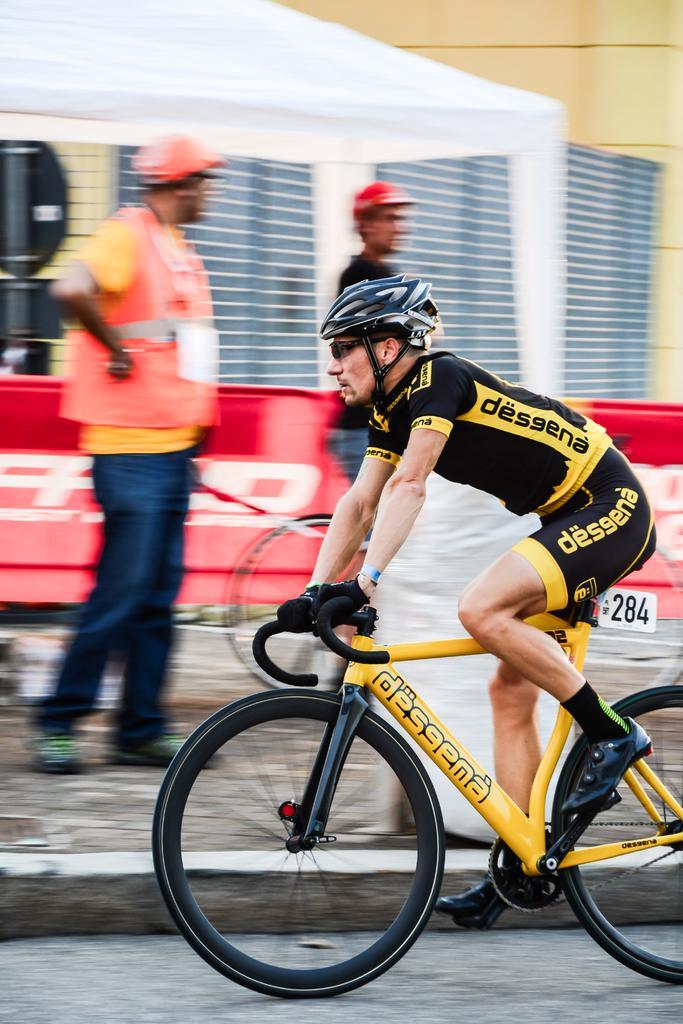Please provide a concise description of this image. In this picture there is a man who is wearing a black t shirt and a helmet on his head is riding a bicycle on the road. At the back there are two men who are standing. There is a number plate on the bicycle. 